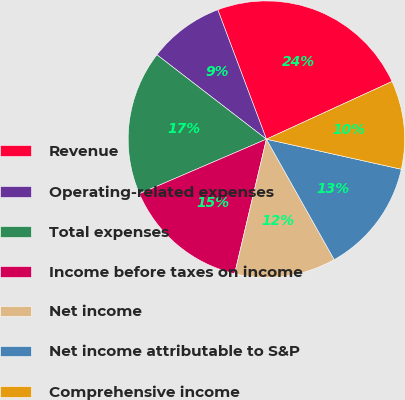Convert chart. <chart><loc_0><loc_0><loc_500><loc_500><pie_chart><fcel>Revenue<fcel>Operating-related expenses<fcel>Total expenses<fcel>Income before taxes on income<fcel>Net income<fcel>Net income attributable to S&P<fcel>Comprehensive income<nl><fcel>23.87%<fcel>8.83%<fcel>16.91%<fcel>14.85%<fcel>11.85%<fcel>13.35%<fcel>10.34%<nl></chart> 